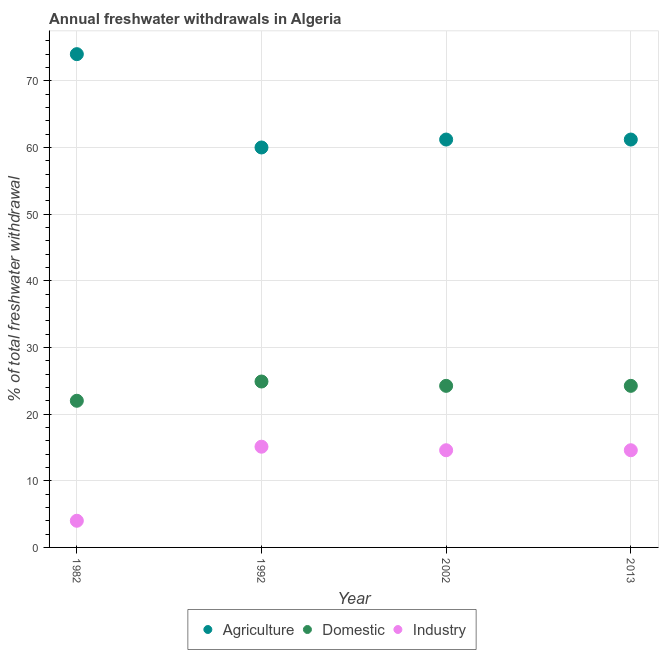Is the number of dotlines equal to the number of legend labels?
Offer a very short reply. Yes. What is the percentage of freshwater withdrawal for agriculture in 2002?
Give a very brief answer. 61.19. Across all years, what is the maximum percentage of freshwater withdrawal for industry?
Give a very brief answer. 15.11. In which year was the percentage of freshwater withdrawal for agriculture minimum?
Make the answer very short. 1992. What is the total percentage of freshwater withdrawal for agriculture in the graph?
Offer a terse response. 256.38. What is the difference between the percentage of freshwater withdrawal for industry in 1992 and that in 2013?
Ensure brevity in your answer.  0.53. What is the difference between the percentage of freshwater withdrawal for agriculture in 1982 and the percentage of freshwater withdrawal for industry in 1992?
Your answer should be compact. 58.89. What is the average percentage of freshwater withdrawal for industry per year?
Make the answer very short. 12.07. In the year 1992, what is the difference between the percentage of freshwater withdrawal for agriculture and percentage of freshwater withdrawal for industry?
Your answer should be compact. 44.89. What is the ratio of the percentage of freshwater withdrawal for domestic purposes in 1982 to that in 2013?
Provide a short and direct response. 0.91. Is the percentage of freshwater withdrawal for domestic purposes in 1992 less than that in 2002?
Provide a succinct answer. No. What is the difference between the highest and the second highest percentage of freshwater withdrawal for domestic purposes?
Give a very brief answer. 0.65. What is the difference between the highest and the lowest percentage of freshwater withdrawal for industry?
Provide a short and direct response. 11.11. Is the sum of the percentage of freshwater withdrawal for domestic purposes in 1982 and 2013 greater than the maximum percentage of freshwater withdrawal for agriculture across all years?
Ensure brevity in your answer.  No. Is it the case that in every year, the sum of the percentage of freshwater withdrawal for agriculture and percentage of freshwater withdrawal for domestic purposes is greater than the percentage of freshwater withdrawal for industry?
Your answer should be compact. Yes. Does the percentage of freshwater withdrawal for agriculture monotonically increase over the years?
Your answer should be compact. No. What is the difference between two consecutive major ticks on the Y-axis?
Keep it short and to the point. 10. Does the graph contain any zero values?
Give a very brief answer. No. How many legend labels are there?
Give a very brief answer. 3. How are the legend labels stacked?
Give a very brief answer. Horizontal. What is the title of the graph?
Give a very brief answer. Annual freshwater withdrawals in Algeria. Does "Infant(male)" appear as one of the legend labels in the graph?
Your answer should be compact. No. What is the label or title of the X-axis?
Provide a succinct answer. Year. What is the label or title of the Y-axis?
Offer a terse response. % of total freshwater withdrawal. What is the % of total freshwater withdrawal of Agriculture in 1982?
Ensure brevity in your answer.  74. What is the % of total freshwater withdrawal of Domestic in 1982?
Give a very brief answer. 22. What is the % of total freshwater withdrawal of Domestic in 1992?
Provide a succinct answer. 24.89. What is the % of total freshwater withdrawal of Industry in 1992?
Give a very brief answer. 15.11. What is the % of total freshwater withdrawal of Agriculture in 2002?
Provide a succinct answer. 61.19. What is the % of total freshwater withdrawal in Domestic in 2002?
Your answer should be compact. 24.24. What is the % of total freshwater withdrawal in Industry in 2002?
Offer a terse response. 14.58. What is the % of total freshwater withdrawal of Agriculture in 2013?
Give a very brief answer. 61.19. What is the % of total freshwater withdrawal of Domestic in 2013?
Your answer should be very brief. 24.24. What is the % of total freshwater withdrawal of Industry in 2013?
Your answer should be very brief. 14.58. Across all years, what is the maximum % of total freshwater withdrawal of Domestic?
Your response must be concise. 24.89. Across all years, what is the maximum % of total freshwater withdrawal of Industry?
Your response must be concise. 15.11. Across all years, what is the minimum % of total freshwater withdrawal in Industry?
Ensure brevity in your answer.  4. What is the total % of total freshwater withdrawal of Agriculture in the graph?
Provide a short and direct response. 256.38. What is the total % of total freshwater withdrawal in Domestic in the graph?
Provide a succinct answer. 95.37. What is the total % of total freshwater withdrawal of Industry in the graph?
Provide a succinct answer. 48.27. What is the difference between the % of total freshwater withdrawal of Agriculture in 1982 and that in 1992?
Give a very brief answer. 14. What is the difference between the % of total freshwater withdrawal in Domestic in 1982 and that in 1992?
Ensure brevity in your answer.  -2.89. What is the difference between the % of total freshwater withdrawal of Industry in 1982 and that in 1992?
Your answer should be compact. -11.11. What is the difference between the % of total freshwater withdrawal in Agriculture in 1982 and that in 2002?
Your answer should be very brief. 12.81. What is the difference between the % of total freshwater withdrawal in Domestic in 1982 and that in 2002?
Make the answer very short. -2.24. What is the difference between the % of total freshwater withdrawal in Industry in 1982 and that in 2002?
Provide a succinct answer. -10.58. What is the difference between the % of total freshwater withdrawal in Agriculture in 1982 and that in 2013?
Ensure brevity in your answer.  12.81. What is the difference between the % of total freshwater withdrawal in Domestic in 1982 and that in 2013?
Give a very brief answer. -2.24. What is the difference between the % of total freshwater withdrawal of Industry in 1982 and that in 2013?
Offer a terse response. -10.58. What is the difference between the % of total freshwater withdrawal of Agriculture in 1992 and that in 2002?
Make the answer very short. -1.19. What is the difference between the % of total freshwater withdrawal in Domestic in 1992 and that in 2002?
Keep it short and to the point. 0.65. What is the difference between the % of total freshwater withdrawal in Industry in 1992 and that in 2002?
Give a very brief answer. 0.53. What is the difference between the % of total freshwater withdrawal of Agriculture in 1992 and that in 2013?
Your answer should be compact. -1.19. What is the difference between the % of total freshwater withdrawal of Domestic in 1992 and that in 2013?
Keep it short and to the point. 0.65. What is the difference between the % of total freshwater withdrawal in Industry in 1992 and that in 2013?
Give a very brief answer. 0.53. What is the difference between the % of total freshwater withdrawal in Agriculture in 2002 and that in 2013?
Your answer should be very brief. 0. What is the difference between the % of total freshwater withdrawal in Domestic in 2002 and that in 2013?
Offer a very short reply. 0. What is the difference between the % of total freshwater withdrawal in Agriculture in 1982 and the % of total freshwater withdrawal in Domestic in 1992?
Your response must be concise. 49.11. What is the difference between the % of total freshwater withdrawal in Agriculture in 1982 and the % of total freshwater withdrawal in Industry in 1992?
Your answer should be compact. 58.89. What is the difference between the % of total freshwater withdrawal of Domestic in 1982 and the % of total freshwater withdrawal of Industry in 1992?
Ensure brevity in your answer.  6.89. What is the difference between the % of total freshwater withdrawal in Agriculture in 1982 and the % of total freshwater withdrawal in Domestic in 2002?
Provide a succinct answer. 49.76. What is the difference between the % of total freshwater withdrawal of Agriculture in 1982 and the % of total freshwater withdrawal of Industry in 2002?
Offer a terse response. 59.42. What is the difference between the % of total freshwater withdrawal of Domestic in 1982 and the % of total freshwater withdrawal of Industry in 2002?
Offer a terse response. 7.42. What is the difference between the % of total freshwater withdrawal in Agriculture in 1982 and the % of total freshwater withdrawal in Domestic in 2013?
Make the answer very short. 49.76. What is the difference between the % of total freshwater withdrawal of Agriculture in 1982 and the % of total freshwater withdrawal of Industry in 2013?
Keep it short and to the point. 59.42. What is the difference between the % of total freshwater withdrawal in Domestic in 1982 and the % of total freshwater withdrawal in Industry in 2013?
Your answer should be very brief. 7.42. What is the difference between the % of total freshwater withdrawal in Agriculture in 1992 and the % of total freshwater withdrawal in Domestic in 2002?
Your answer should be compact. 35.76. What is the difference between the % of total freshwater withdrawal in Agriculture in 1992 and the % of total freshwater withdrawal in Industry in 2002?
Your answer should be compact. 45.42. What is the difference between the % of total freshwater withdrawal in Domestic in 1992 and the % of total freshwater withdrawal in Industry in 2002?
Offer a very short reply. 10.31. What is the difference between the % of total freshwater withdrawal in Agriculture in 1992 and the % of total freshwater withdrawal in Domestic in 2013?
Provide a succinct answer. 35.76. What is the difference between the % of total freshwater withdrawal in Agriculture in 1992 and the % of total freshwater withdrawal in Industry in 2013?
Provide a short and direct response. 45.42. What is the difference between the % of total freshwater withdrawal in Domestic in 1992 and the % of total freshwater withdrawal in Industry in 2013?
Make the answer very short. 10.31. What is the difference between the % of total freshwater withdrawal of Agriculture in 2002 and the % of total freshwater withdrawal of Domestic in 2013?
Provide a short and direct response. 36.95. What is the difference between the % of total freshwater withdrawal of Agriculture in 2002 and the % of total freshwater withdrawal of Industry in 2013?
Make the answer very short. 46.61. What is the difference between the % of total freshwater withdrawal of Domestic in 2002 and the % of total freshwater withdrawal of Industry in 2013?
Your answer should be compact. 9.66. What is the average % of total freshwater withdrawal in Agriculture per year?
Keep it short and to the point. 64.09. What is the average % of total freshwater withdrawal in Domestic per year?
Your answer should be very brief. 23.84. What is the average % of total freshwater withdrawal of Industry per year?
Ensure brevity in your answer.  12.07. In the year 1982, what is the difference between the % of total freshwater withdrawal in Agriculture and % of total freshwater withdrawal in Domestic?
Ensure brevity in your answer.  52. In the year 1982, what is the difference between the % of total freshwater withdrawal in Agriculture and % of total freshwater withdrawal in Industry?
Provide a short and direct response. 70. In the year 1992, what is the difference between the % of total freshwater withdrawal in Agriculture and % of total freshwater withdrawal in Domestic?
Offer a very short reply. 35.11. In the year 1992, what is the difference between the % of total freshwater withdrawal in Agriculture and % of total freshwater withdrawal in Industry?
Keep it short and to the point. 44.89. In the year 1992, what is the difference between the % of total freshwater withdrawal in Domestic and % of total freshwater withdrawal in Industry?
Offer a very short reply. 9.78. In the year 2002, what is the difference between the % of total freshwater withdrawal of Agriculture and % of total freshwater withdrawal of Domestic?
Offer a very short reply. 36.95. In the year 2002, what is the difference between the % of total freshwater withdrawal of Agriculture and % of total freshwater withdrawal of Industry?
Offer a very short reply. 46.61. In the year 2002, what is the difference between the % of total freshwater withdrawal of Domestic and % of total freshwater withdrawal of Industry?
Make the answer very short. 9.66. In the year 2013, what is the difference between the % of total freshwater withdrawal of Agriculture and % of total freshwater withdrawal of Domestic?
Make the answer very short. 36.95. In the year 2013, what is the difference between the % of total freshwater withdrawal of Agriculture and % of total freshwater withdrawal of Industry?
Your answer should be compact. 46.61. In the year 2013, what is the difference between the % of total freshwater withdrawal in Domestic and % of total freshwater withdrawal in Industry?
Keep it short and to the point. 9.66. What is the ratio of the % of total freshwater withdrawal in Agriculture in 1982 to that in 1992?
Your answer should be very brief. 1.23. What is the ratio of the % of total freshwater withdrawal in Domestic in 1982 to that in 1992?
Keep it short and to the point. 0.88. What is the ratio of the % of total freshwater withdrawal of Industry in 1982 to that in 1992?
Your answer should be very brief. 0.26. What is the ratio of the % of total freshwater withdrawal in Agriculture in 1982 to that in 2002?
Your response must be concise. 1.21. What is the ratio of the % of total freshwater withdrawal of Domestic in 1982 to that in 2002?
Your answer should be compact. 0.91. What is the ratio of the % of total freshwater withdrawal in Industry in 1982 to that in 2002?
Make the answer very short. 0.27. What is the ratio of the % of total freshwater withdrawal of Agriculture in 1982 to that in 2013?
Offer a very short reply. 1.21. What is the ratio of the % of total freshwater withdrawal in Domestic in 1982 to that in 2013?
Offer a very short reply. 0.91. What is the ratio of the % of total freshwater withdrawal of Industry in 1982 to that in 2013?
Make the answer very short. 0.27. What is the ratio of the % of total freshwater withdrawal in Agriculture in 1992 to that in 2002?
Make the answer very short. 0.98. What is the ratio of the % of total freshwater withdrawal of Domestic in 1992 to that in 2002?
Give a very brief answer. 1.03. What is the ratio of the % of total freshwater withdrawal in Industry in 1992 to that in 2002?
Your answer should be very brief. 1.04. What is the ratio of the % of total freshwater withdrawal in Agriculture in 1992 to that in 2013?
Give a very brief answer. 0.98. What is the ratio of the % of total freshwater withdrawal of Domestic in 1992 to that in 2013?
Your answer should be very brief. 1.03. What is the ratio of the % of total freshwater withdrawal of Industry in 1992 to that in 2013?
Your response must be concise. 1.04. What is the ratio of the % of total freshwater withdrawal in Agriculture in 2002 to that in 2013?
Your answer should be compact. 1. What is the ratio of the % of total freshwater withdrawal in Industry in 2002 to that in 2013?
Provide a succinct answer. 1. What is the difference between the highest and the second highest % of total freshwater withdrawal of Agriculture?
Give a very brief answer. 12.81. What is the difference between the highest and the second highest % of total freshwater withdrawal of Domestic?
Make the answer very short. 0.65. What is the difference between the highest and the second highest % of total freshwater withdrawal in Industry?
Make the answer very short. 0.53. What is the difference between the highest and the lowest % of total freshwater withdrawal of Domestic?
Offer a very short reply. 2.89. What is the difference between the highest and the lowest % of total freshwater withdrawal in Industry?
Make the answer very short. 11.11. 